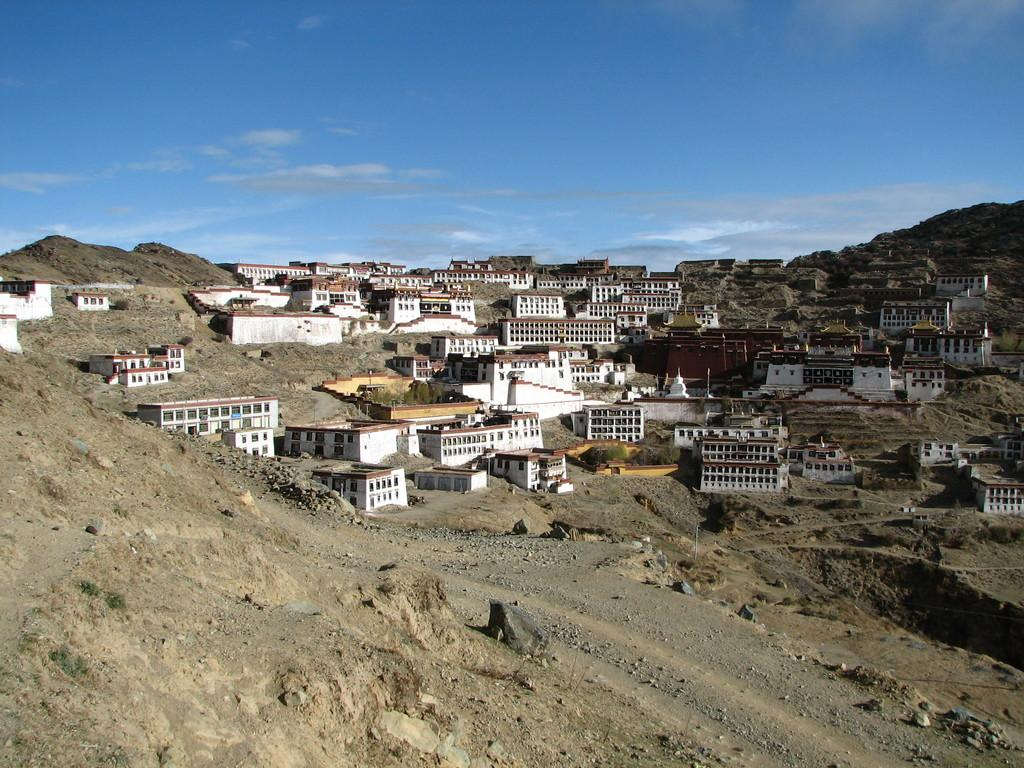What type of structures can be seen in the image? There are buildings in the image. What can be seen in the background of the image? There are clouds and the sky visible in the background of the image. What is on the ground in the front of the image? There are stones on the ground in the front of the image. How many clocks are hanging on the buildings in the image? There is no mention of clocks in the image, so it is impossible to determine how many there are. 